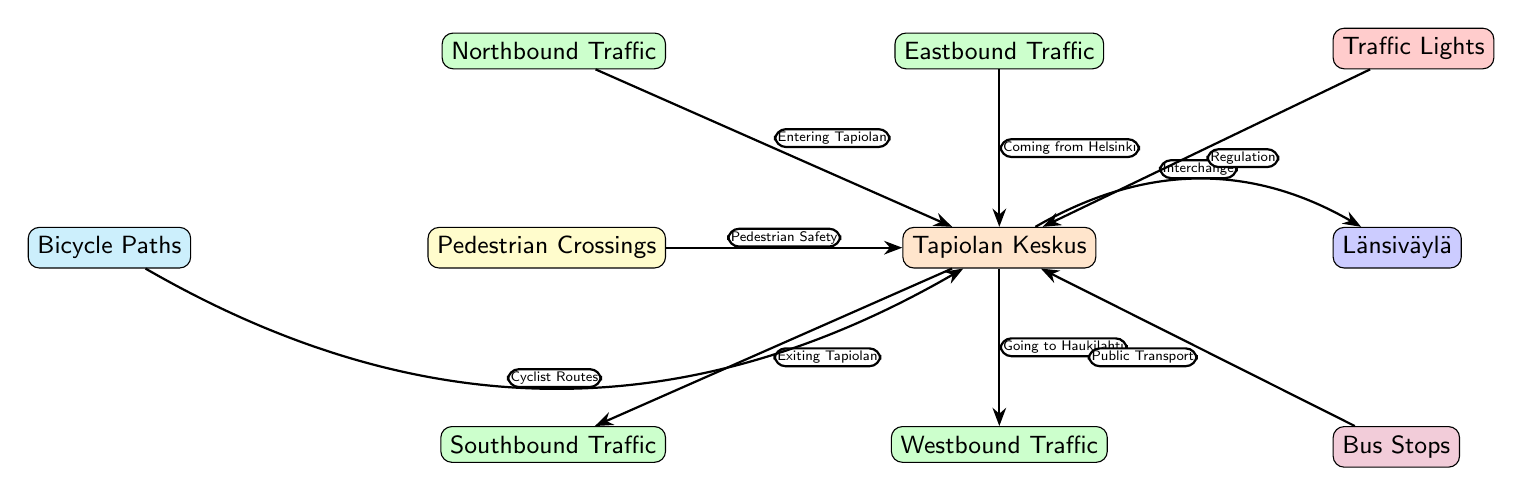What is the main location depicted in the diagram? The diagram identifies "Tapiolan Keskus" as the central node, which is simply labeled in the diagram as the primary location of interest.
Answer: Tapiolan Keskus How many types of traffic are indicated in the diagram? The diagram shows four specific types of traffic: Northbound, Southbound, Eastbound, and Westbound, which are clearly represented as distinct nodes connected with arrows.
Answer: Four What does the orange node represent? The orange node is labeled "Tapiolan Keskus," which serves as a hub for the traffic flow in the diagram and is the main location under analysis.
Answer: Tapiolan Keskus Which direction does the traffic from Helsinki enter Tapiolan? The diagram indicates "Coming from Helsinki" as an arrow directing towards the "Tapiolan Keskus," confirming that this is the entry point for traffic from Helsinki.
Answer: Eastbound Traffic How are pedestrian crossings represented in the diagram? The diagram shows pedestrian crossings as a yellow node labeled "Pedestrian Crossings," illustrating their role in the traffic flow at the intersection.
Answer: Pedestrian Crossings What type of routes are indicated as entering from the left side of the diagram? The diagram specifies "Cyclist Routes," represented by a blue label that connects with the central node, which indicates a flow of traffic designated for bicycles.
Answer: Bicycle Paths What role do the traffic lights play in relation to Tapiolan Keskus? The diagram connects the node labeled "Traffic Lights" with an arrow pointing towards "Tapiolan Keskus," indicating their function in regulating the flow of traffic at this intersection.
Answer: Regulation How does traffic exit Tapiolan Keskus heading towards Haukilahti? The "Going to Haukilahti" arrow leads directly from the central node "Tapiolan Keskus" towards the node labeled "Westbound Traffic," demonstrating this flow direction visually.
Answer: Westbound Traffic What is the significance of the color coding in the diagram? The use of color coding differentiates various traffic categories, pedestrian facilities, and regulations, making it easier to visually interpret the types of flows and elements present.
Answer: Color coding 